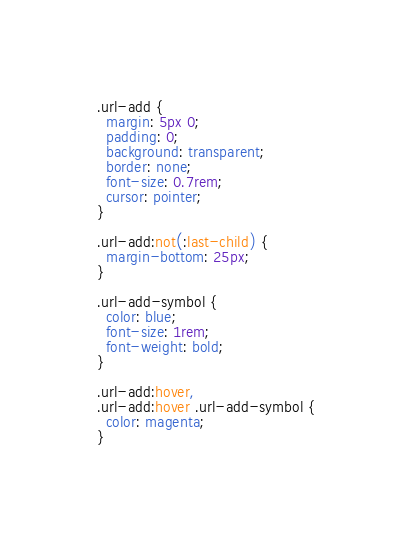Convert code to text. <code><loc_0><loc_0><loc_500><loc_500><_CSS_>
.url-add {
  margin: 5px 0;
  padding: 0;
  background: transparent;
  border: none;
  font-size: 0.7rem;
  cursor: pointer;
}

.url-add:not(:last-child) {
  margin-bottom: 25px;
}

.url-add-symbol {
  color: blue;
  font-size: 1rem;
  font-weight: bold;
}

.url-add:hover,
.url-add:hover .url-add-symbol {
  color: magenta;
}
</code> 